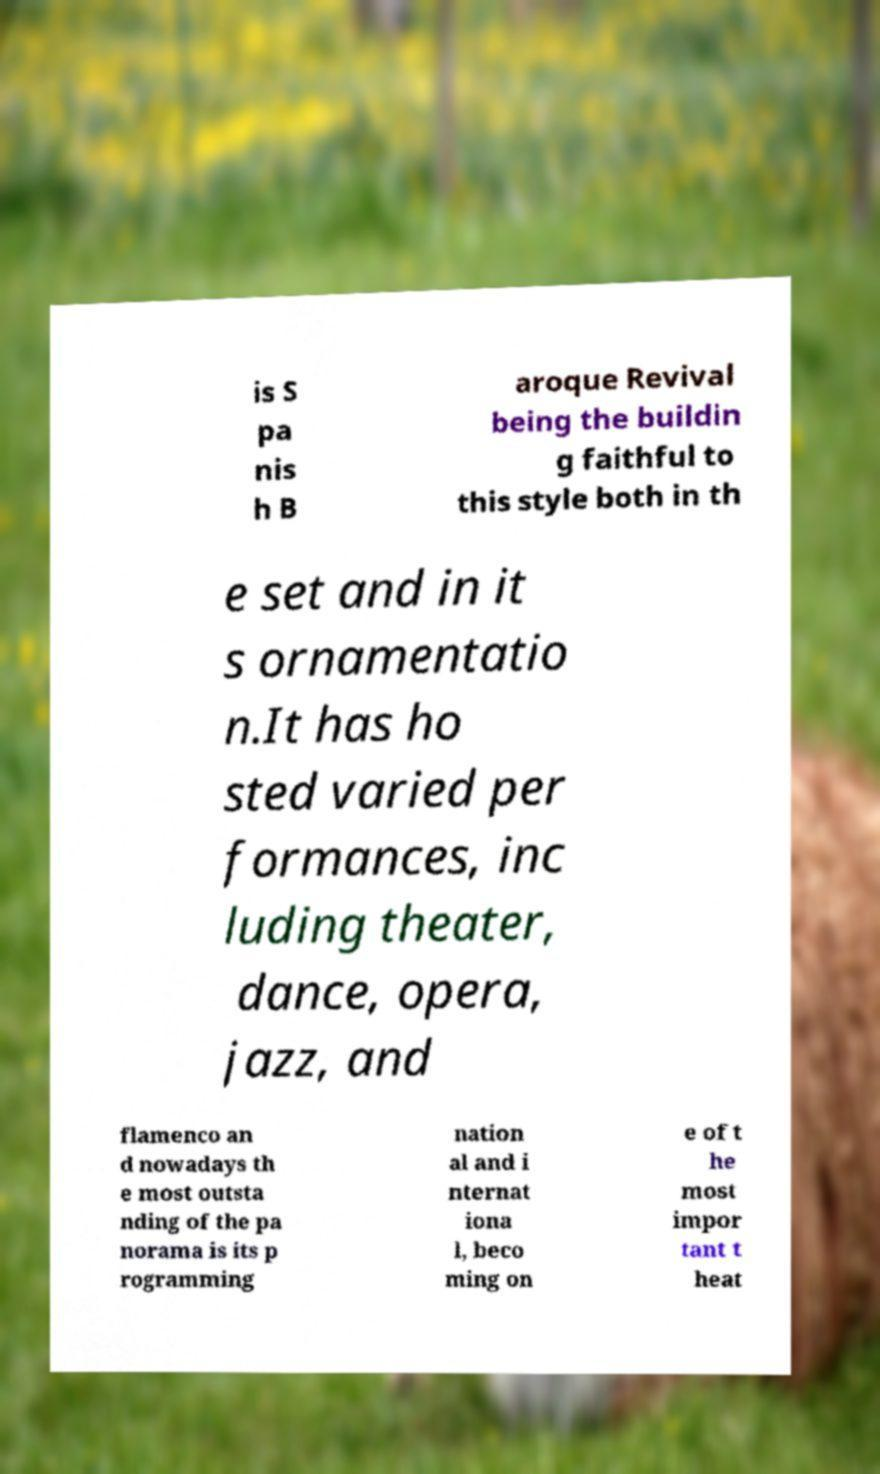There's text embedded in this image that I need extracted. Can you transcribe it verbatim? is S pa nis h B aroque Revival being the buildin g faithful to this style both in th e set and in it s ornamentatio n.It has ho sted varied per formances, inc luding theater, dance, opera, jazz, and flamenco an d nowadays th e most outsta nding of the pa norama is its p rogramming nation al and i nternat iona l, beco ming on e of t he most impor tant t heat 